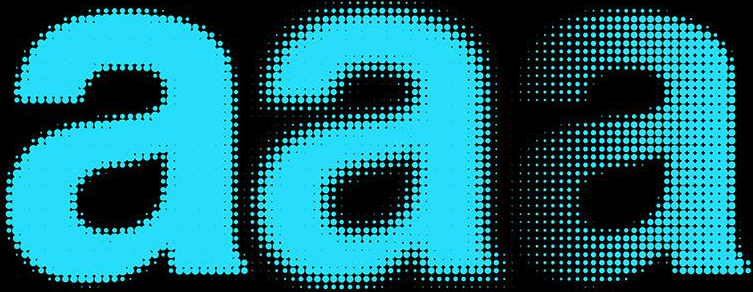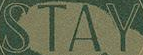What text appears in these images from left to right, separated by a semicolon? aaa; STAY 